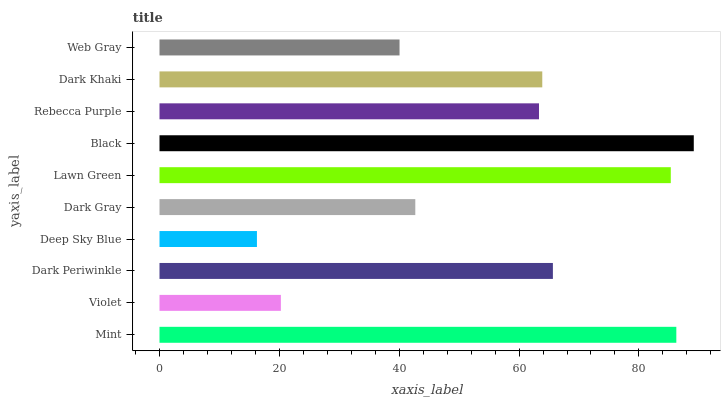Is Deep Sky Blue the minimum?
Answer yes or no. Yes. Is Black the maximum?
Answer yes or no. Yes. Is Violet the minimum?
Answer yes or no. No. Is Violet the maximum?
Answer yes or no. No. Is Mint greater than Violet?
Answer yes or no. Yes. Is Violet less than Mint?
Answer yes or no. Yes. Is Violet greater than Mint?
Answer yes or no. No. Is Mint less than Violet?
Answer yes or no. No. Is Dark Khaki the high median?
Answer yes or no. Yes. Is Rebecca Purple the low median?
Answer yes or no. Yes. Is Black the high median?
Answer yes or no. No. Is Dark Periwinkle the low median?
Answer yes or no. No. 